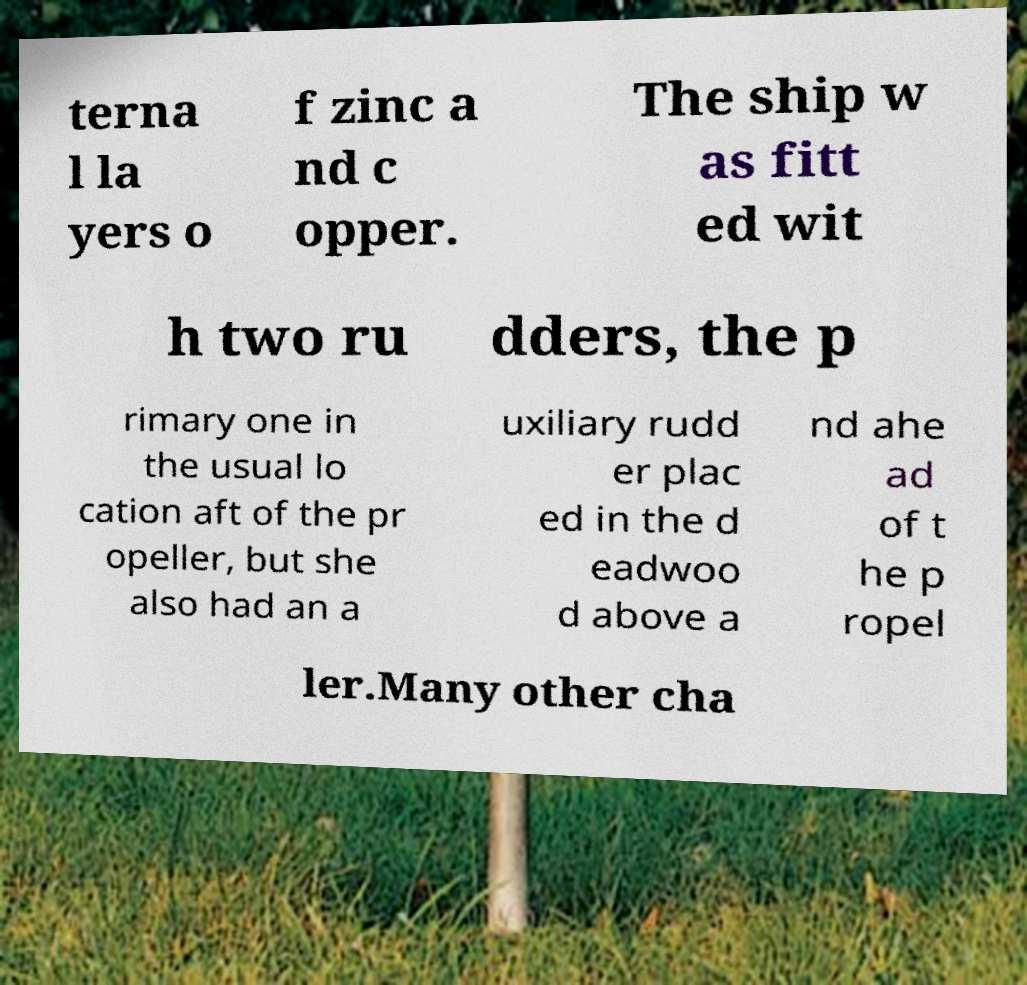Can you accurately transcribe the text from the provided image for me? terna l la yers o f zinc a nd c opper. The ship w as fitt ed wit h two ru dders, the p rimary one in the usual lo cation aft of the pr opeller, but she also had an a uxiliary rudd er plac ed in the d eadwoo d above a nd ahe ad of t he p ropel ler.Many other cha 